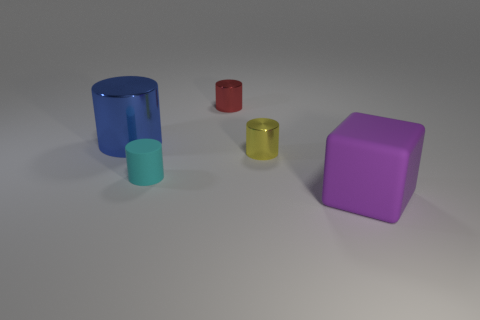Subtract 1 cylinders. How many cylinders are left? 3 Add 3 cyan cylinders. How many objects exist? 8 Subtract all cylinders. How many objects are left? 1 Subtract 0 green cubes. How many objects are left? 5 Subtract all brown cylinders. Subtract all big blue metallic cylinders. How many objects are left? 4 Add 3 red metallic things. How many red metallic things are left? 4 Add 3 red cylinders. How many red cylinders exist? 4 